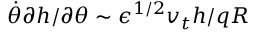Convert formula to latex. <formula><loc_0><loc_0><loc_500><loc_500>\dot { \theta } \partial h / \partial \theta \sim \epsilon ^ { 1 / 2 } v _ { t } h / q R</formula> 